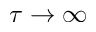Convert formula to latex. <formula><loc_0><loc_0><loc_500><loc_500>\tau \rightarrow \infty</formula> 